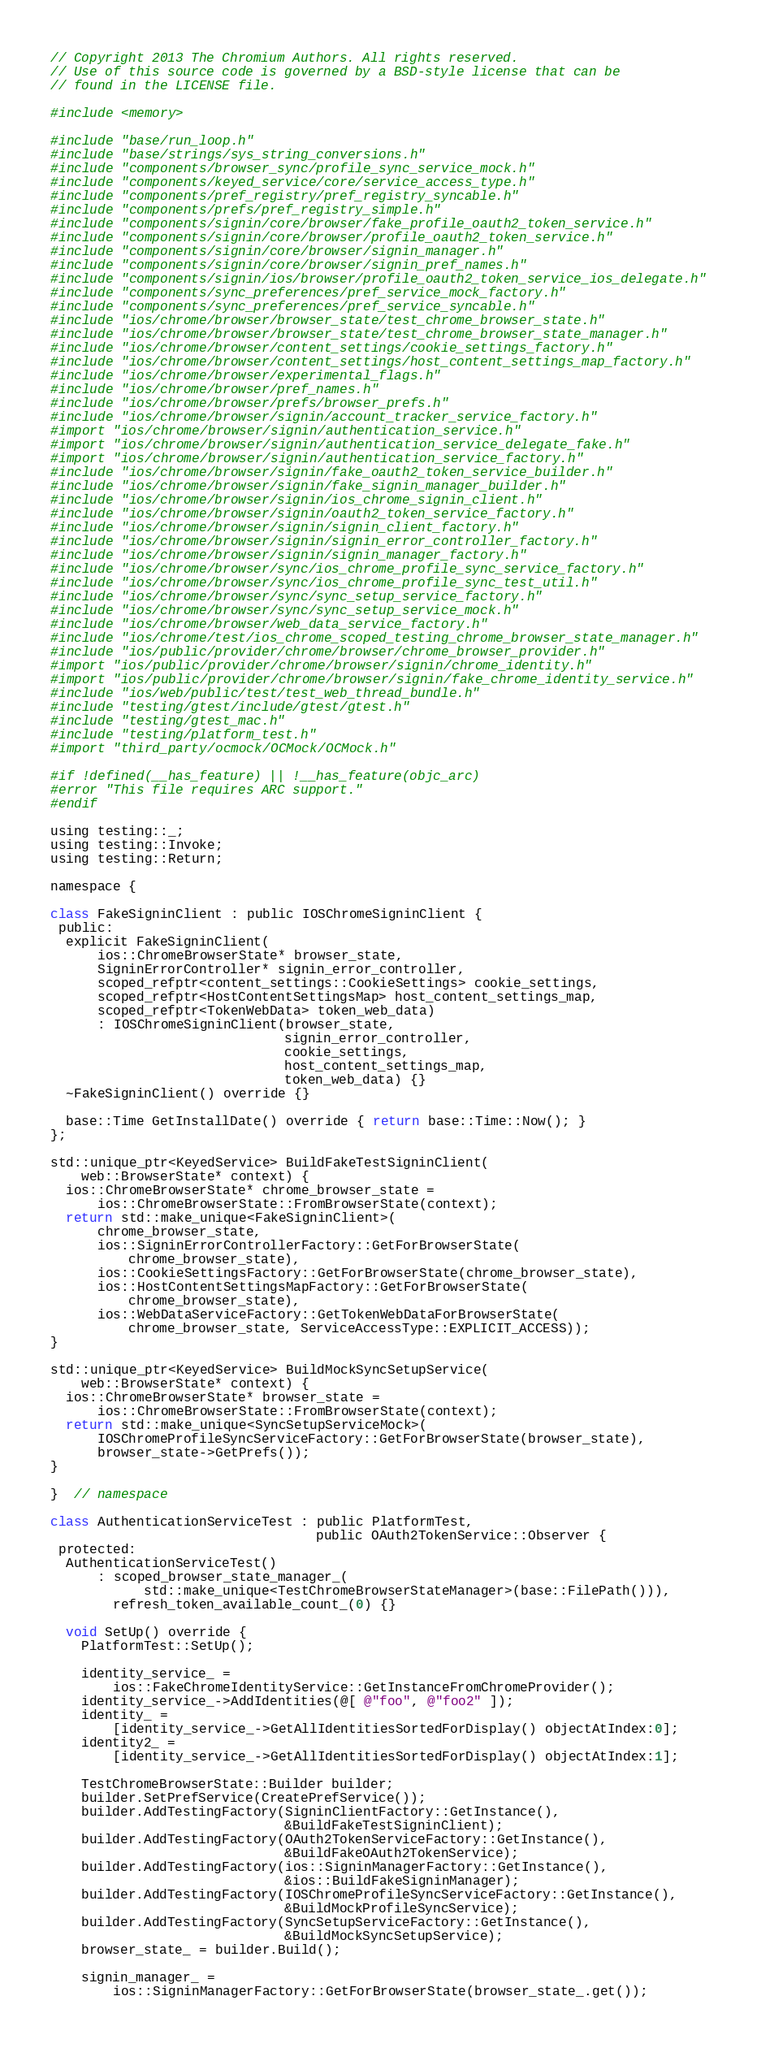Convert code to text. <code><loc_0><loc_0><loc_500><loc_500><_ObjectiveC_>// Copyright 2013 The Chromium Authors. All rights reserved.
// Use of this source code is governed by a BSD-style license that can be
// found in the LICENSE file.

#include <memory>

#include "base/run_loop.h"
#include "base/strings/sys_string_conversions.h"
#include "components/browser_sync/profile_sync_service_mock.h"
#include "components/keyed_service/core/service_access_type.h"
#include "components/pref_registry/pref_registry_syncable.h"
#include "components/prefs/pref_registry_simple.h"
#include "components/signin/core/browser/fake_profile_oauth2_token_service.h"
#include "components/signin/core/browser/profile_oauth2_token_service.h"
#include "components/signin/core/browser/signin_manager.h"
#include "components/signin/core/browser/signin_pref_names.h"
#include "components/signin/ios/browser/profile_oauth2_token_service_ios_delegate.h"
#include "components/sync_preferences/pref_service_mock_factory.h"
#include "components/sync_preferences/pref_service_syncable.h"
#include "ios/chrome/browser/browser_state/test_chrome_browser_state.h"
#include "ios/chrome/browser/browser_state/test_chrome_browser_state_manager.h"
#include "ios/chrome/browser/content_settings/cookie_settings_factory.h"
#include "ios/chrome/browser/content_settings/host_content_settings_map_factory.h"
#include "ios/chrome/browser/experimental_flags.h"
#include "ios/chrome/browser/pref_names.h"
#include "ios/chrome/browser/prefs/browser_prefs.h"
#include "ios/chrome/browser/signin/account_tracker_service_factory.h"
#import "ios/chrome/browser/signin/authentication_service.h"
#import "ios/chrome/browser/signin/authentication_service_delegate_fake.h"
#import "ios/chrome/browser/signin/authentication_service_factory.h"
#include "ios/chrome/browser/signin/fake_oauth2_token_service_builder.h"
#include "ios/chrome/browser/signin/fake_signin_manager_builder.h"
#include "ios/chrome/browser/signin/ios_chrome_signin_client.h"
#include "ios/chrome/browser/signin/oauth2_token_service_factory.h"
#include "ios/chrome/browser/signin/signin_client_factory.h"
#include "ios/chrome/browser/signin/signin_error_controller_factory.h"
#include "ios/chrome/browser/signin/signin_manager_factory.h"
#include "ios/chrome/browser/sync/ios_chrome_profile_sync_service_factory.h"
#include "ios/chrome/browser/sync/ios_chrome_profile_sync_test_util.h"
#include "ios/chrome/browser/sync/sync_setup_service_factory.h"
#include "ios/chrome/browser/sync/sync_setup_service_mock.h"
#include "ios/chrome/browser/web_data_service_factory.h"
#include "ios/chrome/test/ios_chrome_scoped_testing_chrome_browser_state_manager.h"
#include "ios/public/provider/chrome/browser/chrome_browser_provider.h"
#import "ios/public/provider/chrome/browser/signin/chrome_identity.h"
#import "ios/public/provider/chrome/browser/signin/fake_chrome_identity_service.h"
#include "ios/web/public/test/test_web_thread_bundle.h"
#include "testing/gtest/include/gtest/gtest.h"
#include "testing/gtest_mac.h"
#include "testing/platform_test.h"
#import "third_party/ocmock/OCMock/OCMock.h"

#if !defined(__has_feature) || !__has_feature(objc_arc)
#error "This file requires ARC support."
#endif

using testing::_;
using testing::Invoke;
using testing::Return;

namespace {

class FakeSigninClient : public IOSChromeSigninClient {
 public:
  explicit FakeSigninClient(
      ios::ChromeBrowserState* browser_state,
      SigninErrorController* signin_error_controller,
      scoped_refptr<content_settings::CookieSettings> cookie_settings,
      scoped_refptr<HostContentSettingsMap> host_content_settings_map,
      scoped_refptr<TokenWebData> token_web_data)
      : IOSChromeSigninClient(browser_state,
                              signin_error_controller,
                              cookie_settings,
                              host_content_settings_map,
                              token_web_data) {}
  ~FakeSigninClient() override {}

  base::Time GetInstallDate() override { return base::Time::Now(); }
};

std::unique_ptr<KeyedService> BuildFakeTestSigninClient(
    web::BrowserState* context) {
  ios::ChromeBrowserState* chrome_browser_state =
      ios::ChromeBrowserState::FromBrowserState(context);
  return std::make_unique<FakeSigninClient>(
      chrome_browser_state,
      ios::SigninErrorControllerFactory::GetForBrowserState(
          chrome_browser_state),
      ios::CookieSettingsFactory::GetForBrowserState(chrome_browser_state),
      ios::HostContentSettingsMapFactory::GetForBrowserState(
          chrome_browser_state),
      ios::WebDataServiceFactory::GetTokenWebDataForBrowserState(
          chrome_browser_state, ServiceAccessType::EXPLICIT_ACCESS));
}

std::unique_ptr<KeyedService> BuildMockSyncSetupService(
    web::BrowserState* context) {
  ios::ChromeBrowserState* browser_state =
      ios::ChromeBrowserState::FromBrowserState(context);
  return std::make_unique<SyncSetupServiceMock>(
      IOSChromeProfileSyncServiceFactory::GetForBrowserState(browser_state),
      browser_state->GetPrefs());
}

}  // namespace

class AuthenticationServiceTest : public PlatformTest,
                                  public OAuth2TokenService::Observer {
 protected:
  AuthenticationServiceTest()
      : scoped_browser_state_manager_(
            std::make_unique<TestChromeBrowserStateManager>(base::FilePath())),
        refresh_token_available_count_(0) {}

  void SetUp() override {
    PlatformTest::SetUp();

    identity_service_ =
        ios::FakeChromeIdentityService::GetInstanceFromChromeProvider();
    identity_service_->AddIdentities(@[ @"foo", @"foo2" ]);
    identity_ =
        [identity_service_->GetAllIdentitiesSortedForDisplay() objectAtIndex:0];
    identity2_ =
        [identity_service_->GetAllIdentitiesSortedForDisplay() objectAtIndex:1];

    TestChromeBrowserState::Builder builder;
    builder.SetPrefService(CreatePrefService());
    builder.AddTestingFactory(SigninClientFactory::GetInstance(),
                              &BuildFakeTestSigninClient);
    builder.AddTestingFactory(OAuth2TokenServiceFactory::GetInstance(),
                              &BuildFakeOAuth2TokenService);
    builder.AddTestingFactory(ios::SigninManagerFactory::GetInstance(),
                              &ios::BuildFakeSigninManager);
    builder.AddTestingFactory(IOSChromeProfileSyncServiceFactory::GetInstance(),
                              &BuildMockProfileSyncService);
    builder.AddTestingFactory(SyncSetupServiceFactory::GetInstance(),
                              &BuildMockSyncSetupService);
    browser_state_ = builder.Build();

    signin_manager_ =
        ios::SigninManagerFactory::GetForBrowserState(browser_state_.get());</code> 